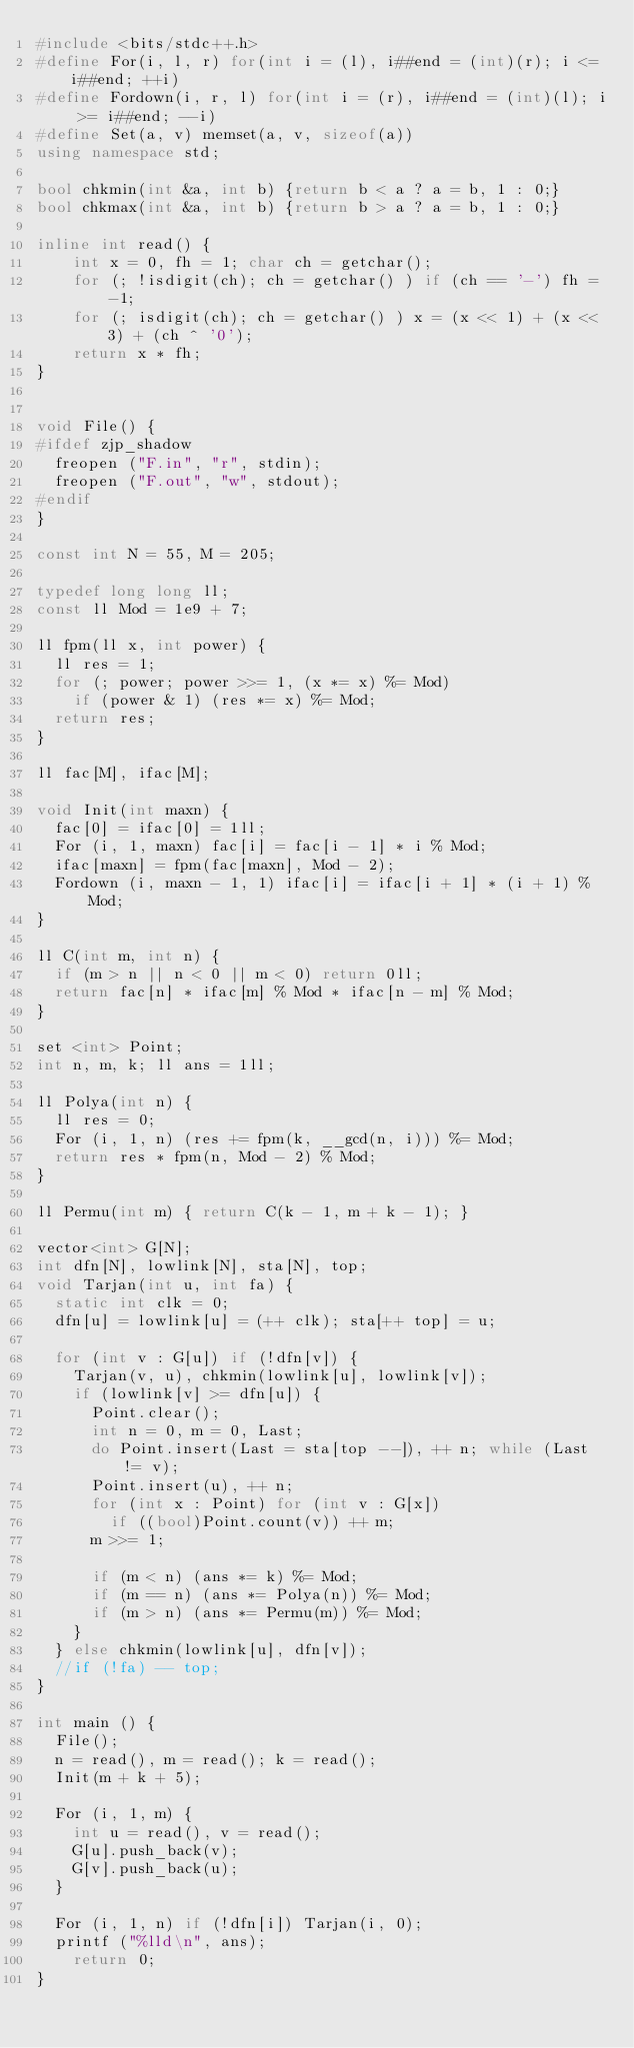<code> <loc_0><loc_0><loc_500><loc_500><_C++_>#include <bits/stdc++.h>
#define For(i, l, r) for(int i = (l), i##end = (int)(r); i <= i##end; ++i)
#define Fordown(i, r, l) for(int i = (r), i##end = (int)(l); i >= i##end; --i)
#define Set(a, v) memset(a, v, sizeof(a))
using namespace std;

bool chkmin(int &a, int b) {return b < a ? a = b, 1 : 0;}
bool chkmax(int &a, int b) {return b > a ? a = b, 1 : 0;}

inline int read() {
    int x = 0, fh = 1; char ch = getchar();
    for (; !isdigit(ch); ch = getchar() ) if (ch == '-') fh = -1;
    for (; isdigit(ch); ch = getchar() ) x = (x << 1) + (x << 3) + (ch ^ '0');
    return x * fh;
}


void File() {
#ifdef zjp_shadow
	freopen ("F.in", "r", stdin);
	freopen ("F.out", "w", stdout);
#endif
}

const int N = 55, M = 205;

typedef long long ll;
const ll Mod = 1e9 + 7;

ll fpm(ll x, int power) {
	ll res = 1;
	for (; power; power >>= 1, (x *= x) %= Mod)
		if (power & 1) (res *= x) %= Mod;
	return res;
}

ll fac[M], ifac[M];

void Init(int maxn) {
	fac[0] = ifac[0] = 1ll;
	For (i, 1, maxn) fac[i] = fac[i - 1] * i % Mod;
	ifac[maxn] = fpm(fac[maxn], Mod - 2);
	Fordown (i, maxn - 1, 1) ifac[i] = ifac[i + 1] * (i + 1) % Mod;
}

ll C(int m, int n) {
	if (m > n || n < 0 || m < 0) return 0ll;
	return fac[n] * ifac[m] % Mod * ifac[n - m] % Mod;
}

set <int> Point;
int n, m, k; ll ans = 1ll;

ll Polya(int n) {
	ll res = 0;
	For (i, 1, n) (res += fpm(k, __gcd(n, i))) %= Mod;
	return res * fpm(n, Mod - 2) % Mod;
}

ll Permu(int m) { return C(k - 1, m + k - 1); }

vector<int> G[N];
int dfn[N], lowlink[N], sta[N], top;
void Tarjan(int u, int fa) {
	static int clk = 0;
	dfn[u] = lowlink[u] = (++ clk); sta[++ top] = u;

	for (int v : G[u]) if (!dfn[v]) {
		Tarjan(v, u), chkmin(lowlink[u], lowlink[v]);
		if (lowlink[v] >= dfn[u]) {
			Point.clear();
			int n = 0, m = 0, Last;
			do Point.insert(Last = sta[top --]), ++ n; while (Last != v);
			Point.insert(u), ++ n;
			for (int x : Point) for (int v : G[x])
				if ((bool)Point.count(v)) ++ m;
			m >>= 1;

			if (m < n) (ans *= k) %= Mod;
			if (m == n) (ans *= Polya(n)) %= Mod;
			if (m > n) (ans *= Permu(m)) %= Mod;
		}
	} else chkmin(lowlink[u], dfn[v]);
	//if (!fa) -- top;
}

int main () {
	File();
	n = read(), m = read(); k = read();
	Init(m + k + 5);

	For (i, 1, m) {
		int u = read(), v = read();
		G[u].push_back(v);
		G[v].push_back(u);
	}

	For (i, 1, n) if (!dfn[i]) Tarjan(i, 0);
	printf ("%lld\n", ans);
    return 0;
}
</code> 